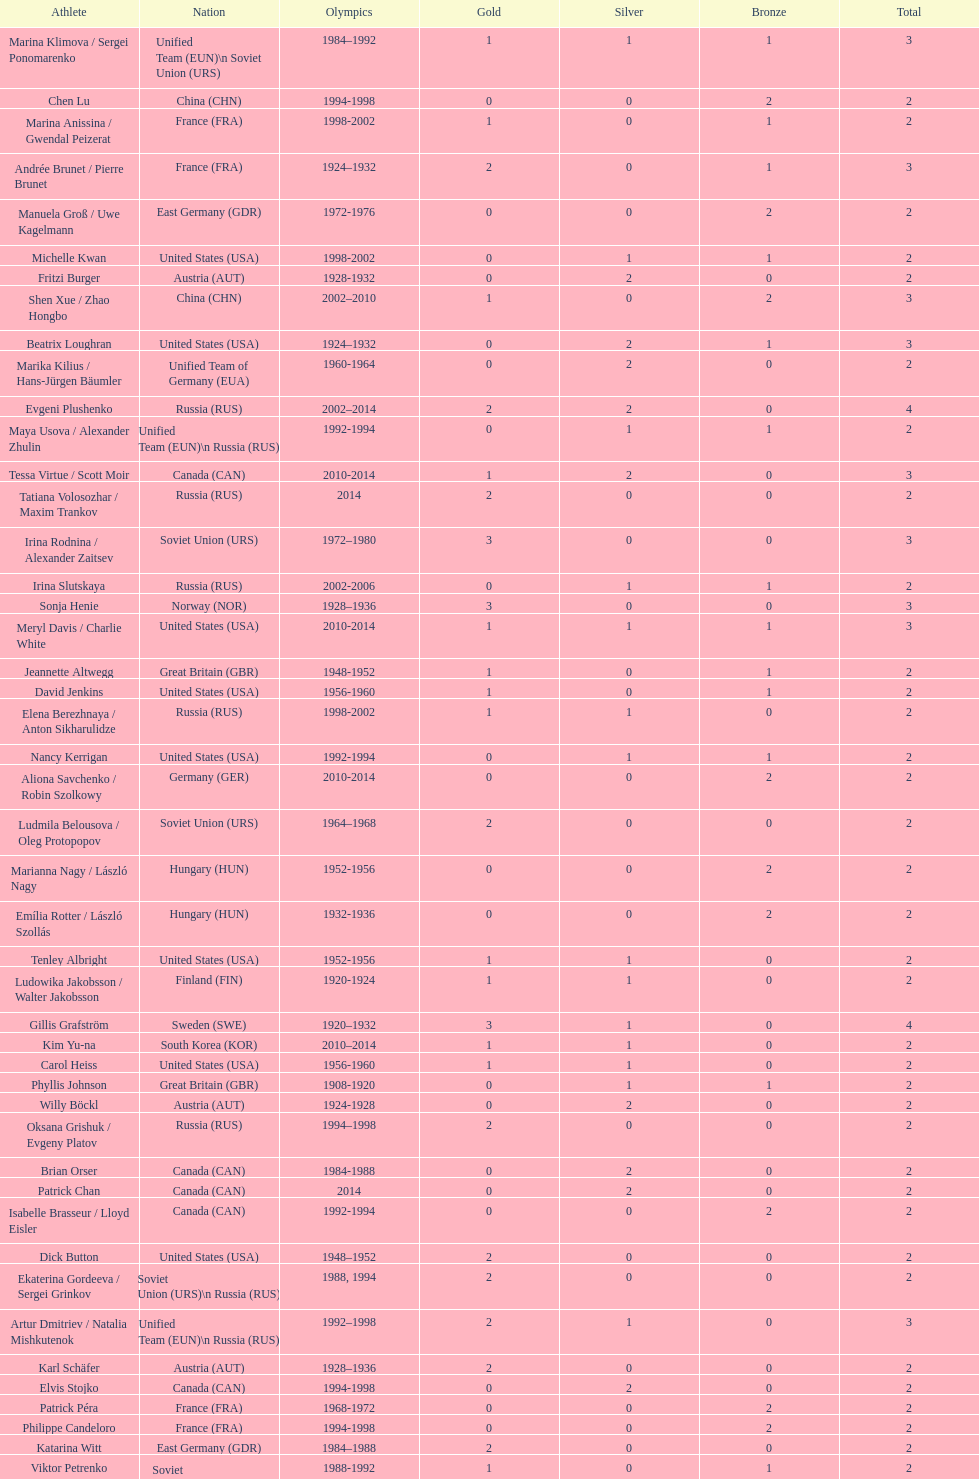What was the greatest number of gold medals won by a single athlete? 3. 